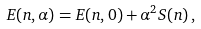Convert formula to latex. <formula><loc_0><loc_0><loc_500><loc_500>E ( n , \alpha ) = E ( n , 0 ) + \alpha ^ { 2 } S ( n ) \, ,</formula> 